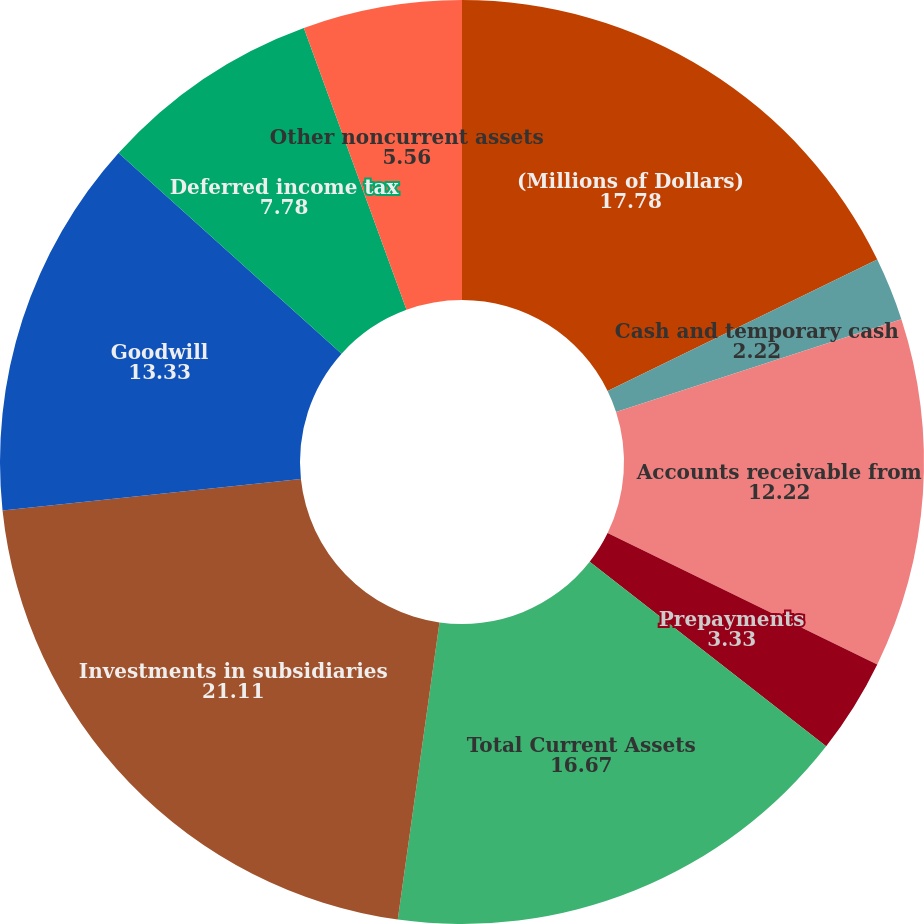Convert chart to OTSL. <chart><loc_0><loc_0><loc_500><loc_500><pie_chart><fcel>(Millions of Dollars)<fcel>Cash and temporary cash<fcel>Special deposits<fcel>Accounts receivable from<fcel>Prepayments<fcel>Total Current Assets<fcel>Investments in subsidiaries<fcel>Goodwill<fcel>Deferred income tax<fcel>Other noncurrent assets<nl><fcel>17.78%<fcel>2.22%<fcel>0.0%<fcel>12.22%<fcel>3.33%<fcel>16.67%<fcel>21.11%<fcel>13.33%<fcel>7.78%<fcel>5.56%<nl></chart> 